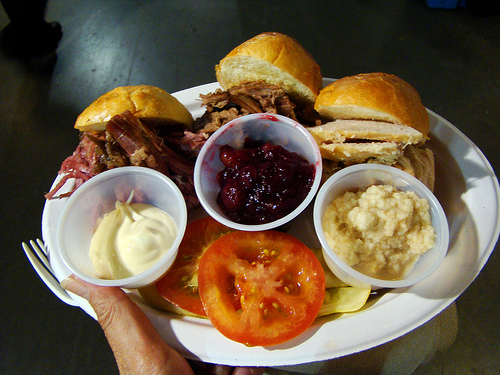<image>
Is there a plate on the foods? No. The plate is not positioned on the foods. They may be near each other, but the plate is not supported by or resting on top of the foods. 